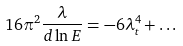Convert formula to latex. <formula><loc_0><loc_0><loc_500><loc_500>1 6 \pi ^ { 2 } \frac { \lambda } { d \ln { E } } = - 6 \lambda ^ { 4 } _ { t } + \dots</formula> 